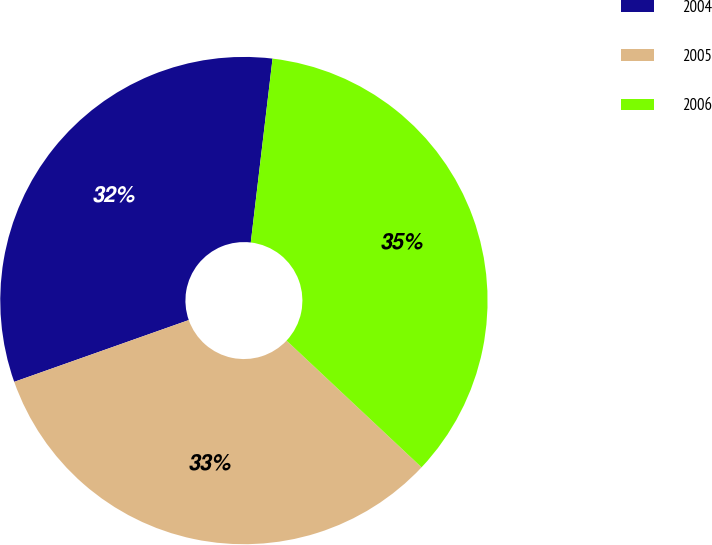<chart> <loc_0><loc_0><loc_500><loc_500><pie_chart><fcel>2004<fcel>2005<fcel>2006<nl><fcel>32.29%<fcel>32.59%<fcel>35.12%<nl></chart> 